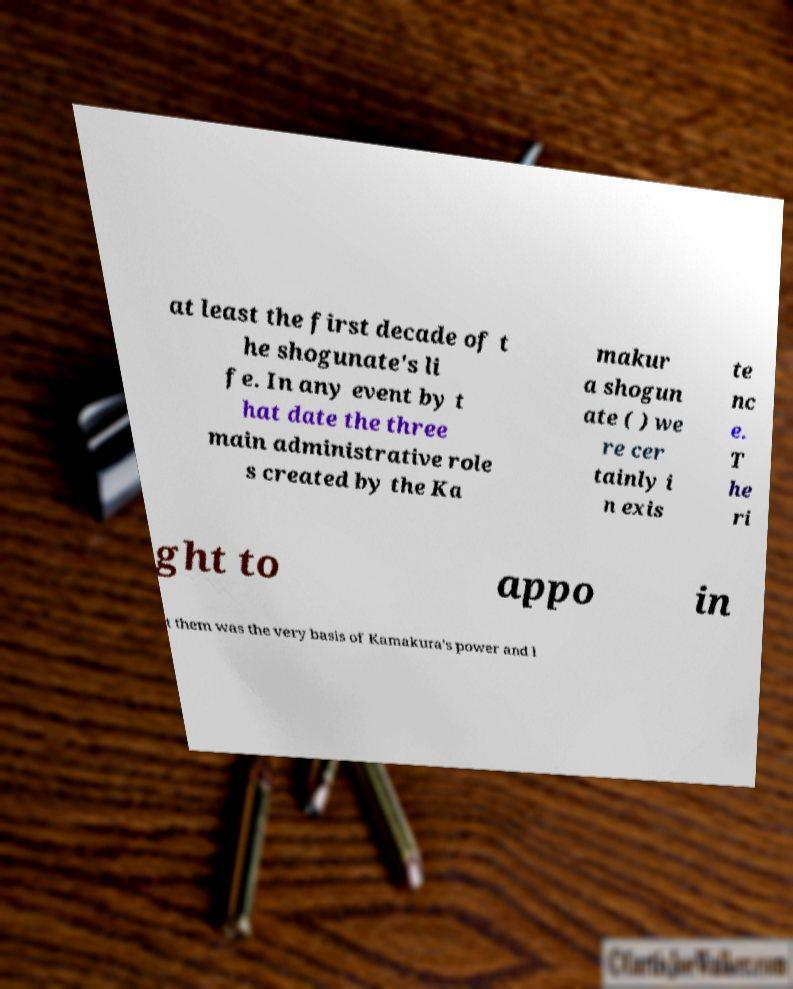What messages or text are displayed in this image? I need them in a readable, typed format. at least the first decade of t he shogunate's li fe. In any event by t hat date the three main administrative role s created by the Ka makur a shogun ate ( ) we re cer tainly i n exis te nc e. T he ri ght to appo in t them was the very basis of Kamakura's power and l 